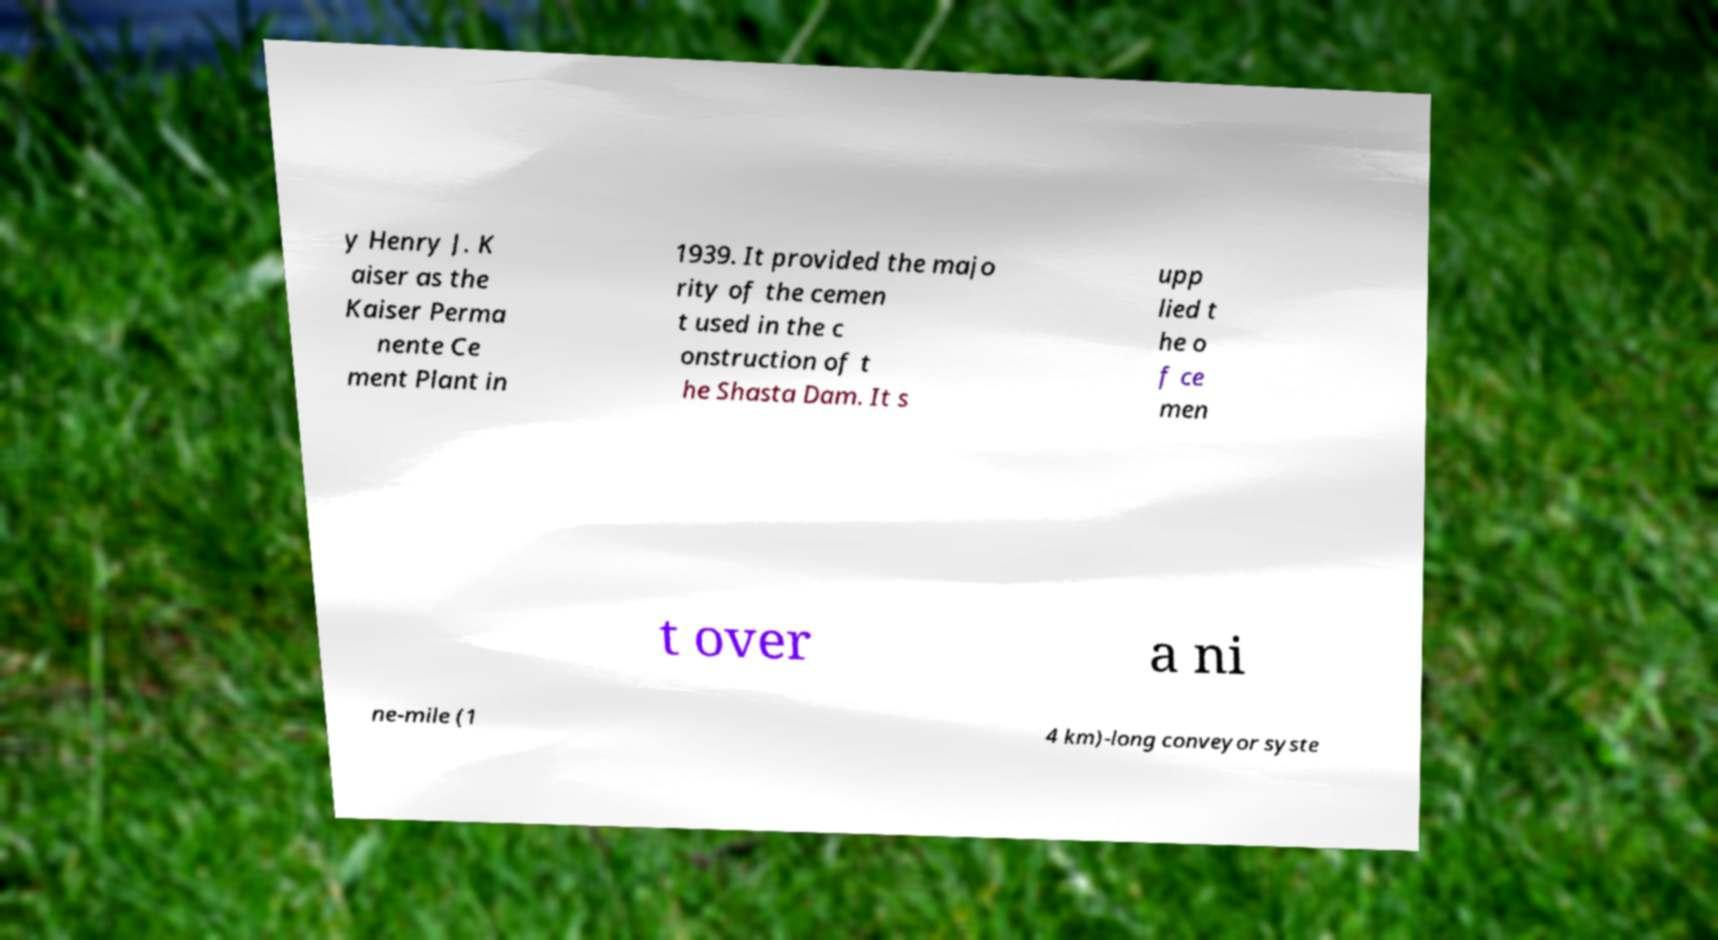Can you accurately transcribe the text from the provided image for me? y Henry J. K aiser as the Kaiser Perma nente Ce ment Plant in 1939. It provided the majo rity of the cemen t used in the c onstruction of t he Shasta Dam. It s upp lied t he o f ce men t over a ni ne-mile (1 4 km)-long conveyor syste 